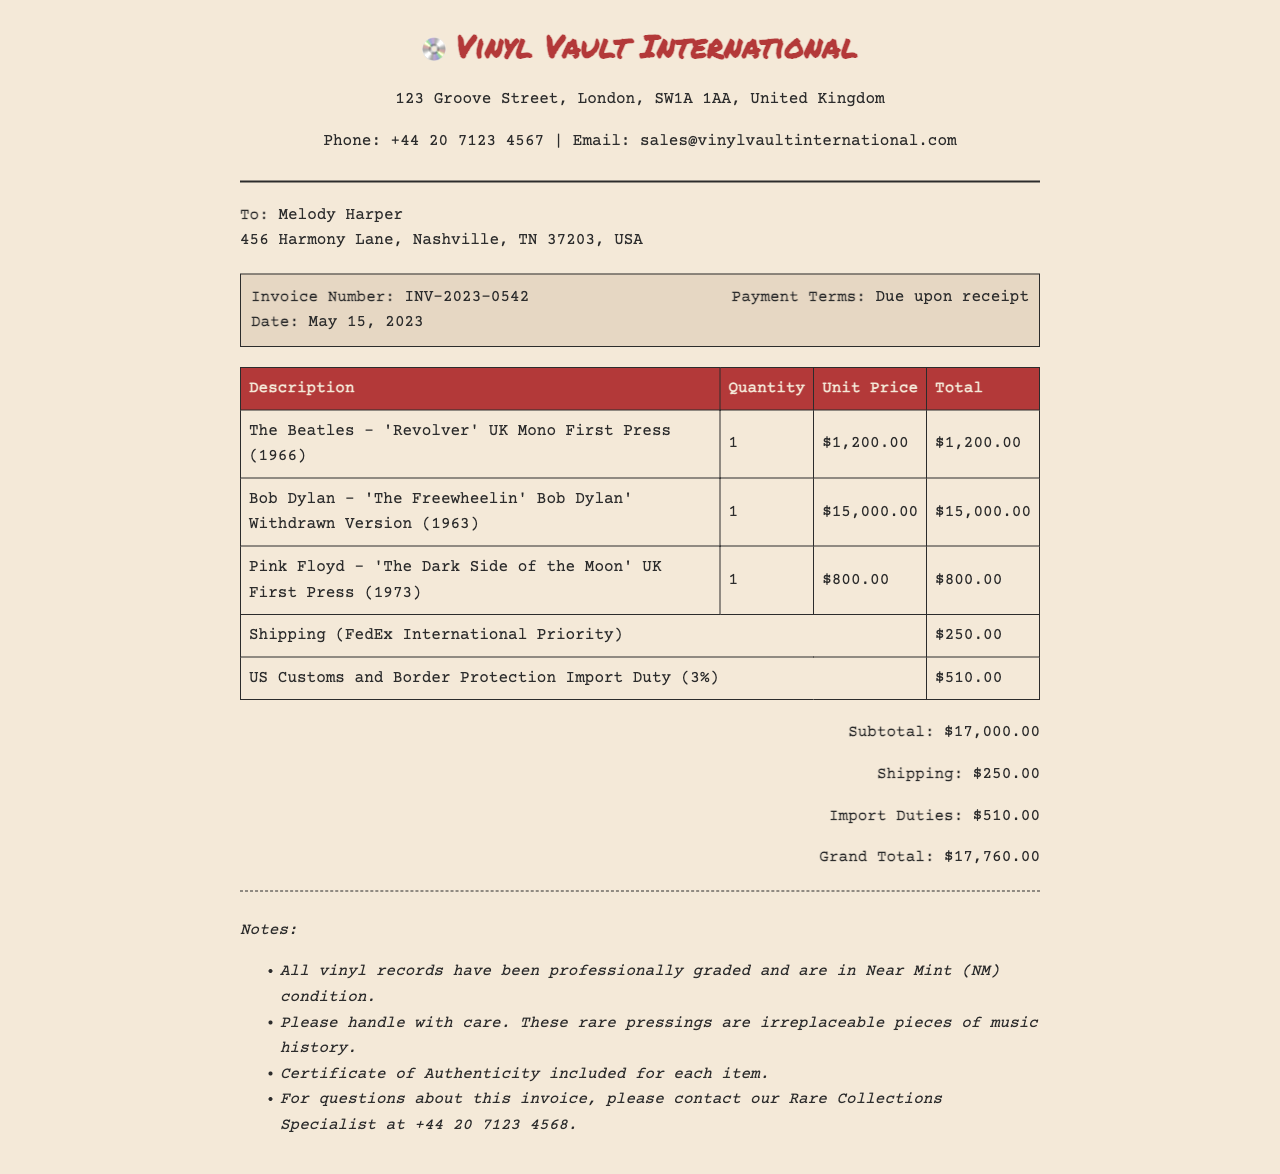What is the invoice number? The invoice number is a unique identifier for the transaction, found in the document.
Answer: INV-2023-0542 What is the grand total of the invoice? The grand total is the final amount due as indicated in the document, including all costs.
Answer: $17,760.00 How much is the import duty? The import duty is a fee based on the total value of the imported goods, stated in the invoice.
Answer: $510.00 What item has the highest unit price? This refers to the most expensive vinyl record listed in the invoice, requiring comparison among all items.
Answer: Bob Dylan - 'The Freewheelin' Bob Dylan' Withdrawn Version (1963) What type of shipping is used for the order? The shipping method specifies how the records will be delivered, which is detailed in the invoice.
Answer: FedEx International Priority What is the payment term stated in the invoice? The payment term specifies when the payment is due for the invoice, which is outlined clearly in the document.
Answer: Due upon receipt How many vinyl records are listed in the invoice? The total number of separate items listed helps in understanding the scope of the purchase.
Answer: 3 What notable detail is included for each record? The invoice provides assurance about the condition and authenticity of the records purchased.
Answer: Certificate of Authenticity What is the shipping cost? The shipping cost is an additional charge listed as part of the total invoice amount.
Answer: $250.00 